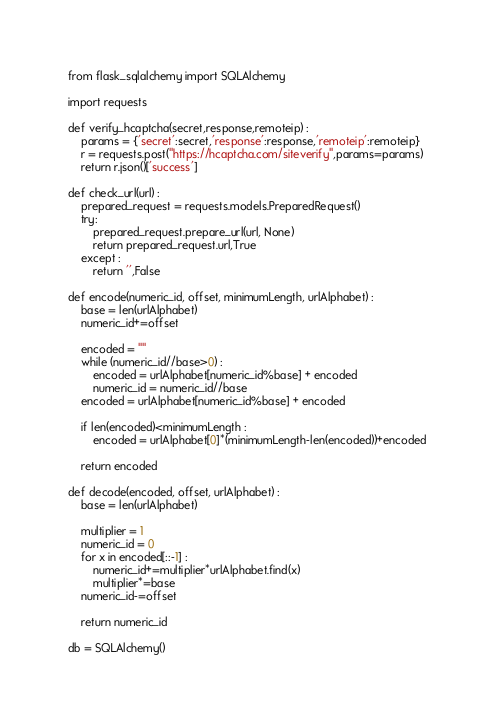Convert code to text. <code><loc_0><loc_0><loc_500><loc_500><_Python_>from flask_sqlalchemy import SQLAlchemy 

import requests

def verify_hcaptcha(secret,response,remoteip) :
    params = {'secret':secret,'response':response,'remoteip':remoteip}
    r = requests.post("https://hcaptcha.com/siteverify",params=params)
    return r.json()['success']

def check_url(url) :
    prepared_request = requests.models.PreparedRequest()
    try:
        prepared_request.prepare_url(url, None)
        return prepared_request.url,True
    except :
        return '',False

def encode(numeric_id, offset, minimumLength, urlAlphabet) :
    base = len(urlAlphabet)
    numeric_id+=offset

    encoded = ""
    while (numeric_id//base>0) :
        encoded = urlAlphabet[numeric_id%base] + encoded
        numeric_id = numeric_id//base
    encoded = urlAlphabet[numeric_id%base] + encoded
    
    if len(encoded)<minimumLength :
        encoded = urlAlphabet[0]*(minimumLength-len(encoded))+encoded
    
    return encoded

def decode(encoded, offset, urlAlphabet) :
    base = len(urlAlphabet)
    
    multiplier = 1
    numeric_id = 0
    for x in encoded[::-1] :
        numeric_id+=multiplier*urlAlphabet.find(x)
        multiplier*=base
    numeric_id-=offset
    
    return numeric_id

db = SQLAlchemy()
</code> 